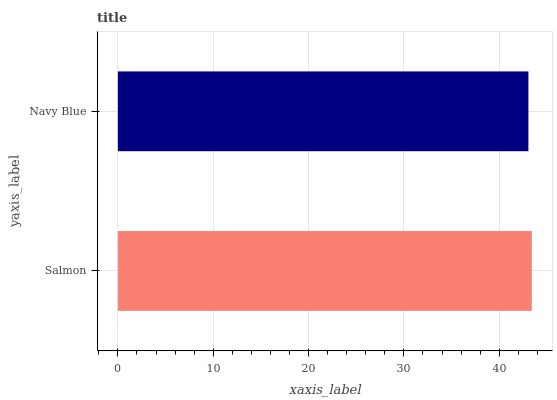Is Navy Blue the minimum?
Answer yes or no. Yes. Is Salmon the maximum?
Answer yes or no. Yes. Is Navy Blue the maximum?
Answer yes or no. No. Is Salmon greater than Navy Blue?
Answer yes or no. Yes. Is Navy Blue less than Salmon?
Answer yes or no. Yes. Is Navy Blue greater than Salmon?
Answer yes or no. No. Is Salmon less than Navy Blue?
Answer yes or no. No. Is Salmon the high median?
Answer yes or no. Yes. Is Navy Blue the low median?
Answer yes or no. Yes. Is Navy Blue the high median?
Answer yes or no. No. Is Salmon the low median?
Answer yes or no. No. 